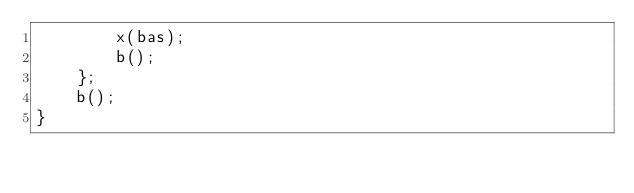Convert code to text. <code><loc_0><loc_0><loc_500><loc_500><_ObjectiveC_>        x(bas);
        b();
    };
    b();
} 
</code> 